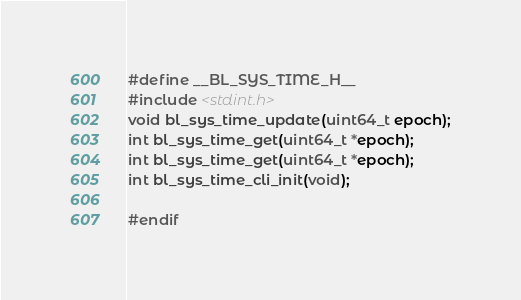Convert code to text. <code><loc_0><loc_0><loc_500><loc_500><_C_>#define __BL_SYS_TIME_H__
#include <stdint.h>
void bl_sys_time_update(uint64_t epoch);
int bl_sys_time_get(uint64_t *epoch);
int bl_sys_time_get(uint64_t *epoch);
int bl_sys_time_cli_init(void);

#endif
</code> 